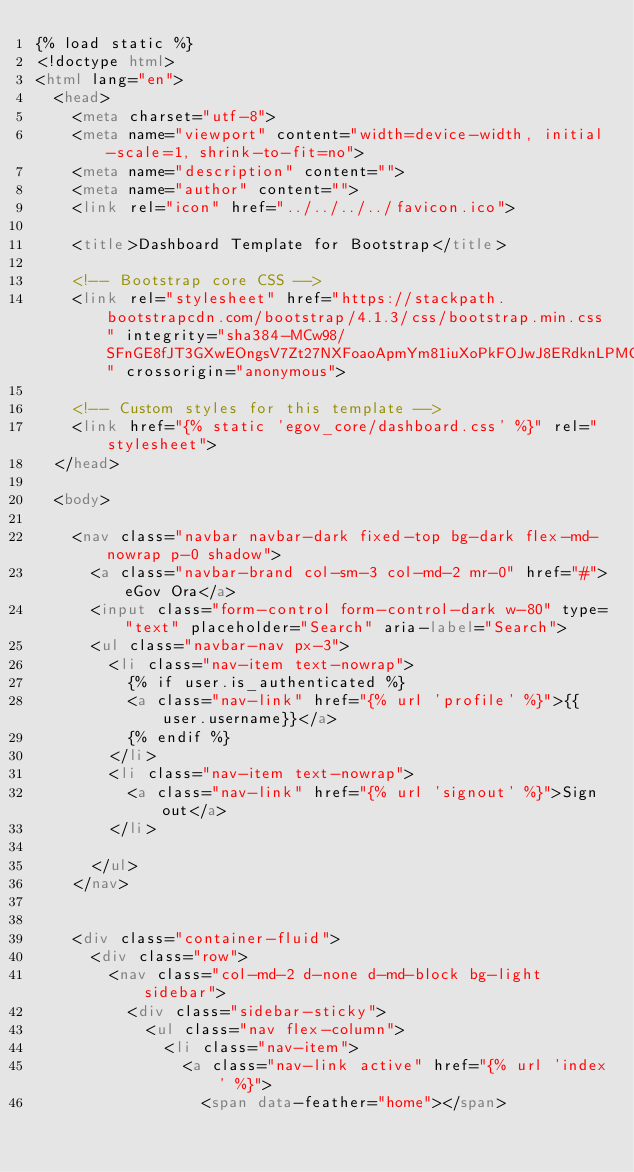Convert code to text. <code><loc_0><loc_0><loc_500><loc_500><_HTML_>{% load static %}
<!doctype html>
<html lang="en">
  <head>
    <meta charset="utf-8">
    <meta name="viewport" content="width=device-width, initial-scale=1, shrink-to-fit=no">
    <meta name="description" content="">
    <meta name="author" content="">
    <link rel="icon" href="../../../../favicon.ico">

    <title>Dashboard Template for Bootstrap</title>

    <!-- Bootstrap core CSS -->
    <link rel="stylesheet" href="https://stackpath.bootstrapcdn.com/bootstrap/4.1.3/css/bootstrap.min.css" integrity="sha384-MCw98/SFnGE8fJT3GXwEOngsV7Zt27NXFoaoApmYm81iuXoPkFOJwJ8ERdknLPMO" crossorigin="anonymous">

    <!-- Custom styles for this template -->
    <link href="{% static 'egov_core/dashboard.css' %}" rel="stylesheet">
  </head>

  <body>
    
    <nav class="navbar navbar-dark fixed-top bg-dark flex-md-nowrap p-0 shadow">
      <a class="navbar-brand col-sm-3 col-md-2 mr-0" href="#">eGov Ora</a>
      <input class="form-control form-control-dark w-80" type="text" placeholder="Search" aria-label="Search">
      <ul class="navbar-nav px-3">
        <li class="nav-item text-nowrap">
          {% if user.is_authenticated %}
          <a class="nav-link" href="{% url 'profile' %}">{{user.username}}</a>
          {% endif %}
        </li>
        <li class="nav-item text-nowrap">
          <a class="nav-link" href="{% url 'signout' %}">Sign out</a>
        </li>
        
      </ul>
    </nav>
  

    <div class="container-fluid">
      <div class="row">
        <nav class="col-md-2 d-none d-md-block bg-light sidebar">
          <div class="sidebar-sticky">
            <ul class="nav flex-column">
              <li class="nav-item">
                <a class="nav-link active" href="{% url 'index' %}">
                  <span data-feather="home"></span></code> 